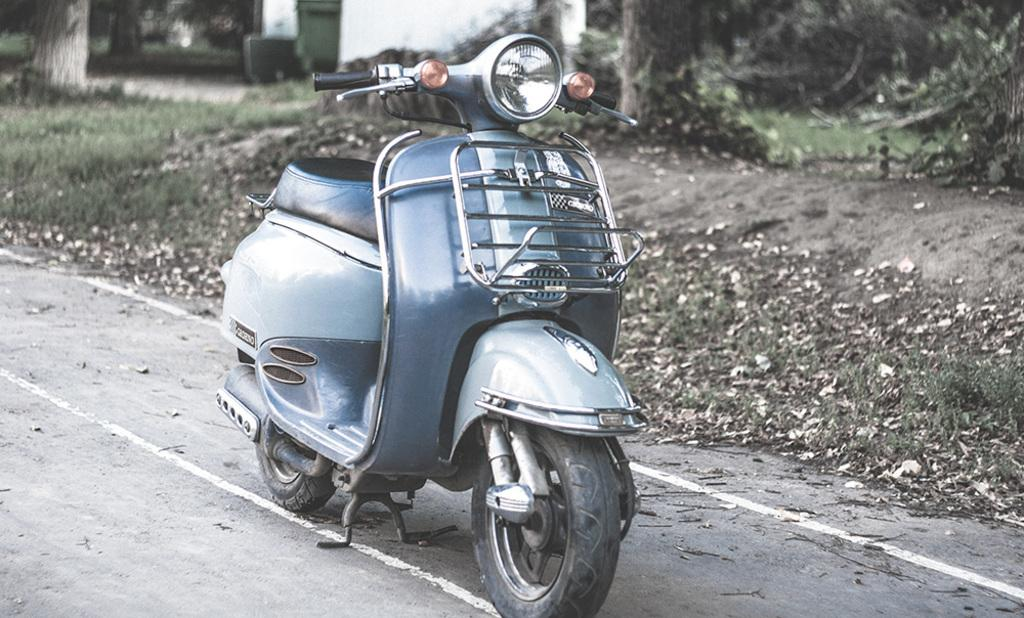What type of vehicle is in the image? There is a scooter in the image. What is visible at the bottom of the image? Grass and leaves are visible at the bottom of the image. What can be seen in the background of the image? Trees are present in the background of the image. What object is used for waste disposal in the image? There is a dustbin in the image. What type of sweater is the scooter wearing in the image? The scooter is not wearing a sweater in the image, as it is an inanimate object and does not wear clothing. 